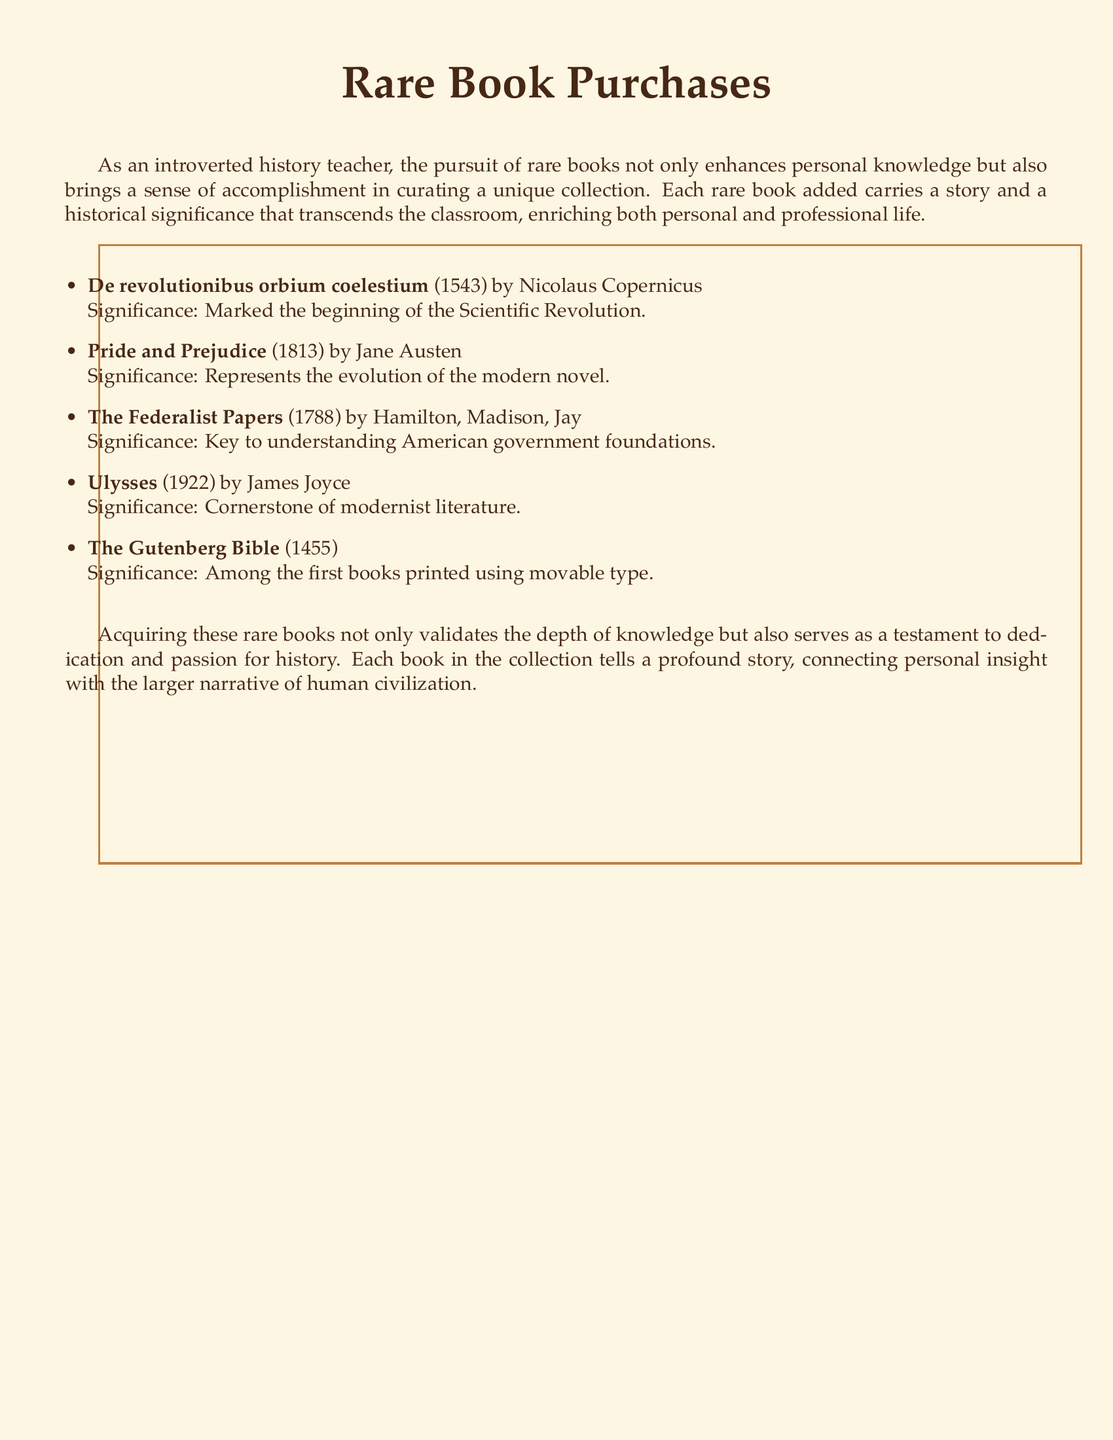What is the title of the first book listed? The title of the first book is stated at the beginning of the list, which is "De revolutionibus orbium coelestium".
Answer: De revolutionibus orbium coelestium Who authored "Pride and Prejudice"? The author's name is mentioned directly in the document, which is Jane Austen.
Answer: Jane Austen In what year was "The Gutenberg Bible" printed? The document specifies the year of printing for "The Gutenberg Bible" as 1455.
Answer: 1455 What significant historical event does "De revolutionibus orbium coelestium" mark the beginning of? The significance listed indicates that this book marked the beginning of the Scientific Revolution.
Answer: Scientific Revolution Which book is considered a cornerstone of modernist literature? The document identifies "Ulysses" as the cornerstone of modernist literature.
Answer: Ulysses How many authors contributed to "The Federalist Papers"? The document lists three authors who contributed to this work: Hamilton, Madison, and Jay, so the total is three.
Answer: Three What does the collection of rare books represent for the collector? The document describes the collection as a testament to dedication and passion for history.
Answer: Dedication and passion for history What year was "Ulysses" published? According to the document, "Ulysses" was published in 1922.
Answer: 1922 